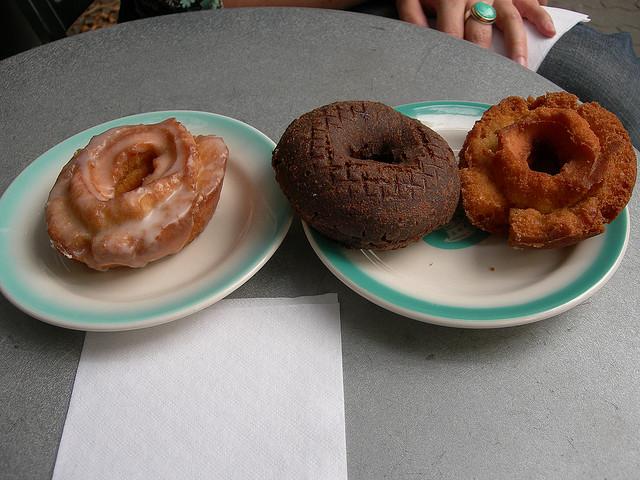Is this a breakfast item?
Give a very brief answer. Yes. How many chocolate donuts are there?
Be succinct. 1. How many doughnuts are there?
Be succinct. 3. What is the donuts on?
Answer briefly. Plate. What is on the woman's finger?
Answer briefly. Ring. How many donuts are picture?
Give a very brief answer. 3. What color table is the food on?
Be succinct. Gray. How many donuts are pictured?
Answer briefly. 3. 